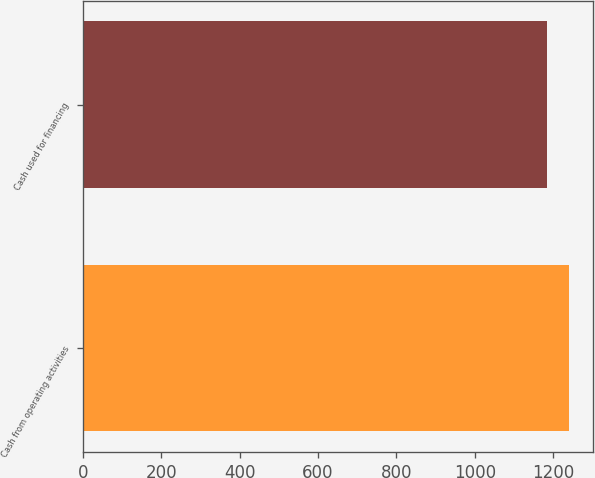<chart> <loc_0><loc_0><loc_500><loc_500><bar_chart><fcel>Cash from operating activities<fcel>Cash used for financing<nl><fcel>1241<fcel>1184<nl></chart> 